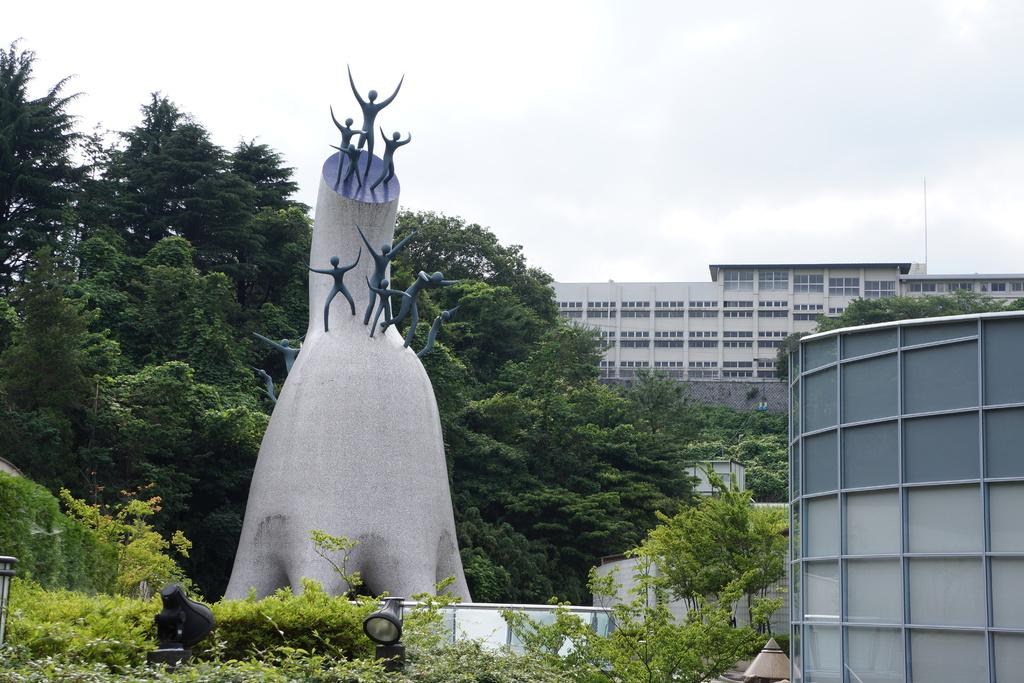What type of structures can be seen in the image? There are buildings in the image. What type of vegetation is present in the image? There are trees and plants in the image. What can be seen in the background of the image? The sky is visible in the background of the image. What grade did the head of the discovery team receive in their last exam? There is no reference to a discovery team, head, or exam in the image, so it is not possible to answer that question. 